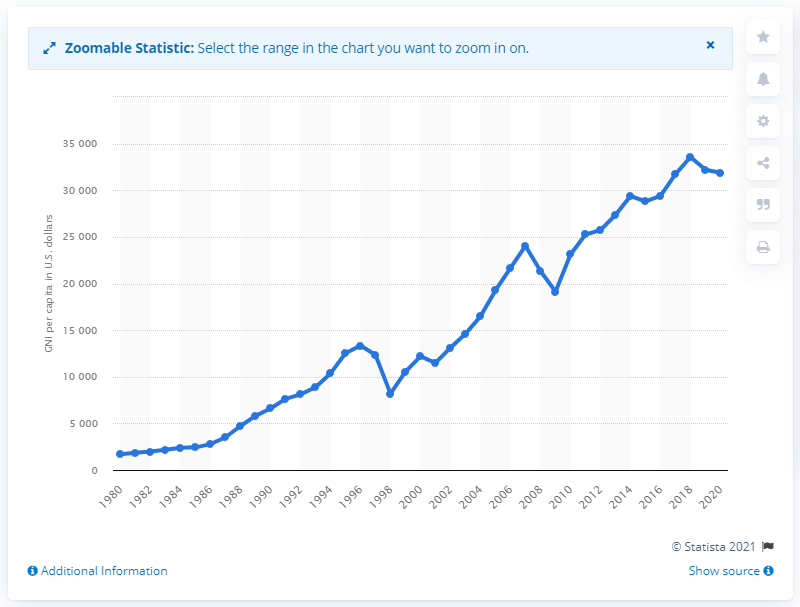Specify some key components in this picture. In 2020, the per capita GNI in South Korea was 31,880.6 USD. In the previous year, the per capita GNI of South Korea was 318,806. 